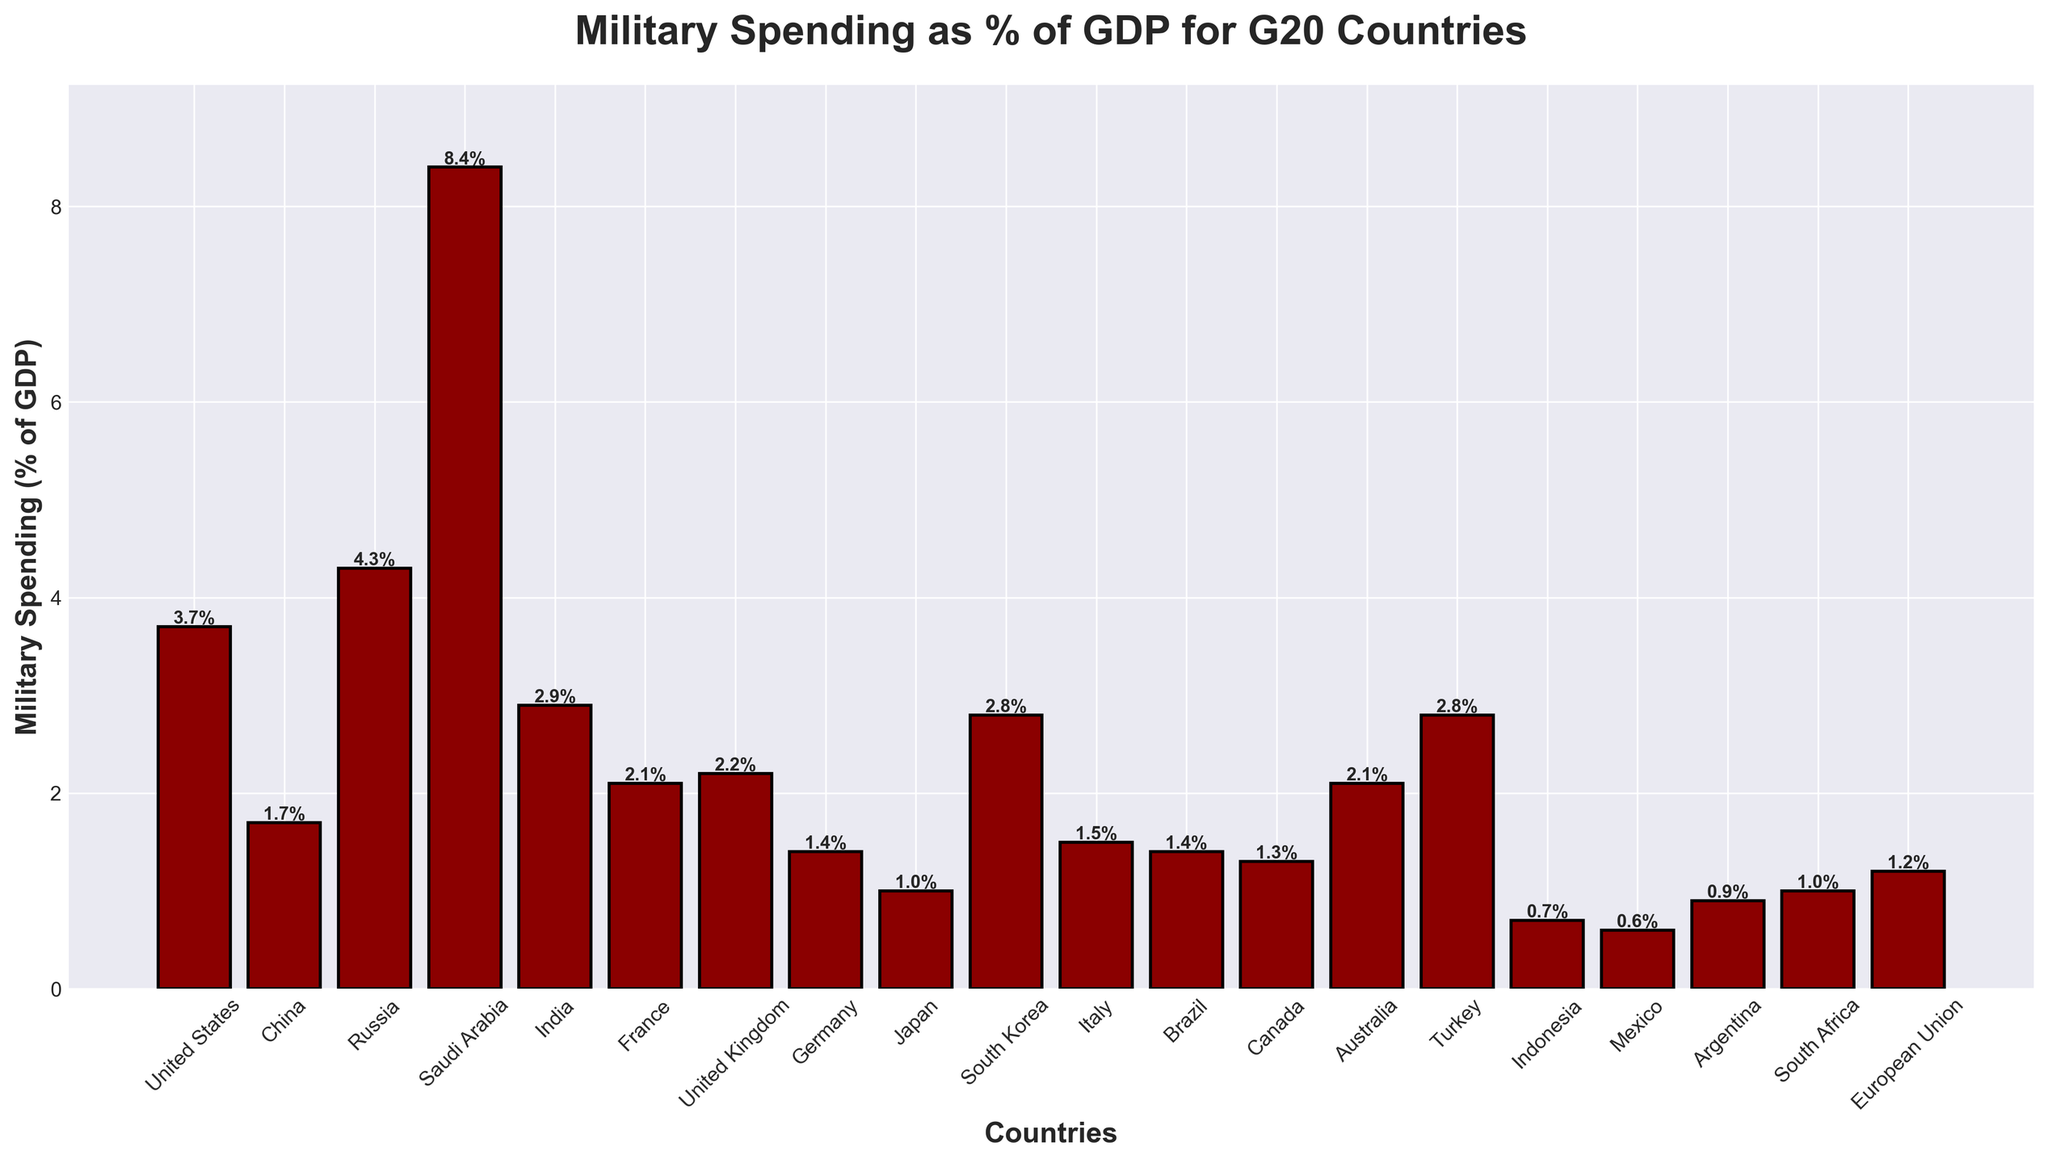Which country has the highest military spending as a percentage of GDP? The bar representing Saudi Arabia in the chart is the tallest, which indicates the highest military spending as a percentage of GDP
Answer: Saudi Arabia How many countries have military spending greater than 3% of their GDP? By examining the bars, we see that the countries with military spending greater than 3% of GDP are the United States, Russia, and Saudi Arabia. Count these bars
Answer: 3 What is the difference in military spending as a percentage of GDP between Russia and China? The figure shows Russia at 4.3% and China at 1.7%. Subtract China's percentage from Russia's percentage
Answer: 2.6% Which country has the lowest military spending as a percentage of GDP? The shortest bar represents Mexico, which indicates the lowest military spending as a percentage of GDP
Answer: Mexico What is the average military spending as a percentage of GDP for the G20 countries with military spending below 1%? The countries below 1% are Indonesia, Mexico, and Argentina. Their percentages are 0.7%, 0.6%, and 0.9% respectively. The average is (0.7 + 0.6 + 0.9) / 3
Answer: 0.73% Between which two countries is there the smallest difference in military spending as a percentage of GDP? Compare the heights of the bars that are closest to each other to find the smallest difference. The smallest difference is between France (2.1%) and Australia (2.1%)
Answer: France and Australia What is the combined military spending as a percentage of GDP for all European Union members shown in the chart (France, Germany, Italy)? Add up the military spending percentages for France (2.1%), Germany (1.4%), and Italy (1.5%): 2.1 + 1.4 + 1.5
Answer: 5.0% Which countries have their military spending as a percentage of GDP marked on top of the bars in bold? By looking at the figure, we see that all countries have their military spending percentages marked on top in bold, as indicated in the code provided
Answer: All countries What is the median value of military spending as a percentage of GDP among G20 countries? Arrange the numbers in ascending order: 0.6, 0.7, 0.9, 1.0, 1.0, 1.2, 1.3, 1.4, 1.4, 1.5, 1.7, 2.1, 2.1, 2.2, 2.8, 2.8, 2.9, 3.7, 4.3, 8.4. The median is the average of the 10th and 11th values: (1.5+1.7)/2
Answer: 1.6% Is South Korea's military spending higher than the average of its neighboring countries (China and Japan)? South Korea spends 2.8%. The average military spending of China (1.7%) and Japan (1.0%) is (1.7 + 1.0) / 2 = 1.35%. Since 2.8% is greater than 1.35%, South Korea spends more than its neighbors on average
Answer: Yes 